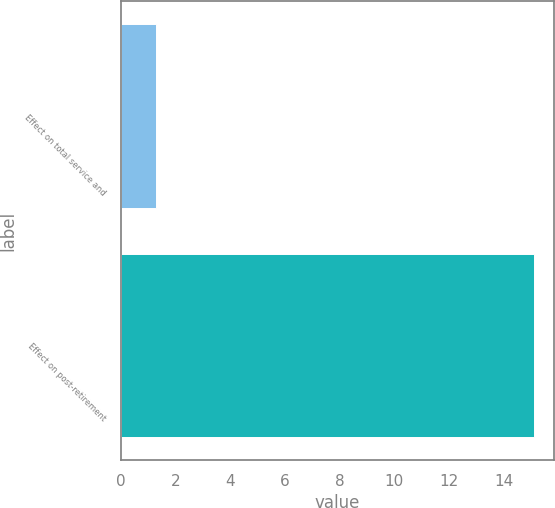<chart> <loc_0><loc_0><loc_500><loc_500><bar_chart><fcel>Effect on total service and<fcel>Effect on post-retirement<nl><fcel>1.3<fcel>15.1<nl></chart> 